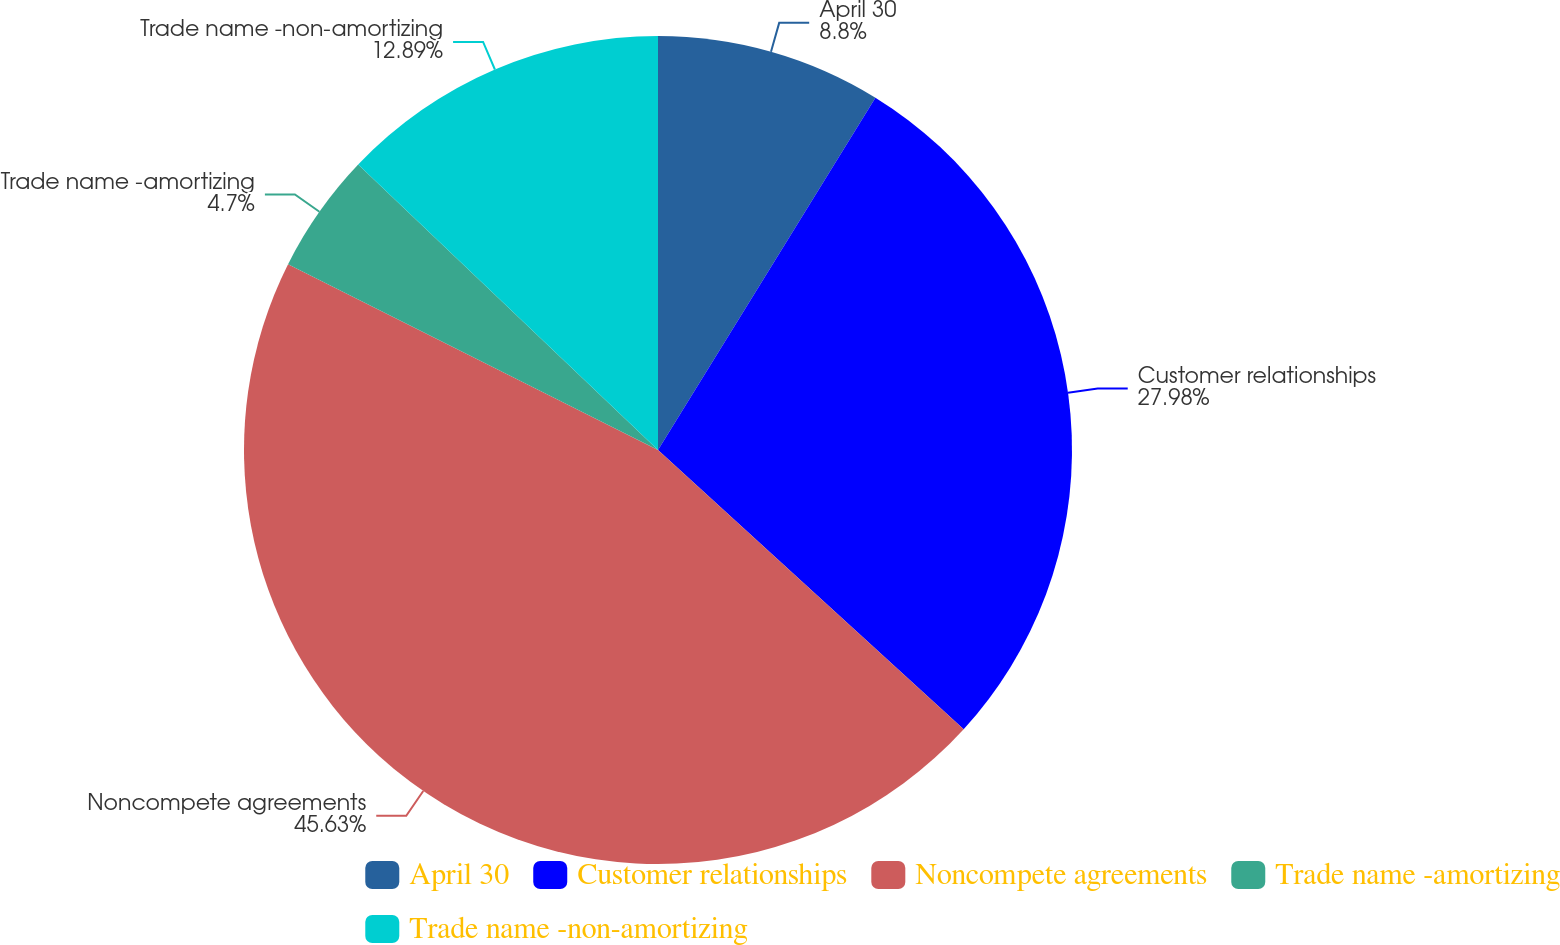Convert chart. <chart><loc_0><loc_0><loc_500><loc_500><pie_chart><fcel>April 30<fcel>Customer relationships<fcel>Noncompete agreements<fcel>Trade name -amortizing<fcel>Trade name -non-amortizing<nl><fcel>8.8%<fcel>27.98%<fcel>45.63%<fcel>4.7%<fcel>12.89%<nl></chart> 